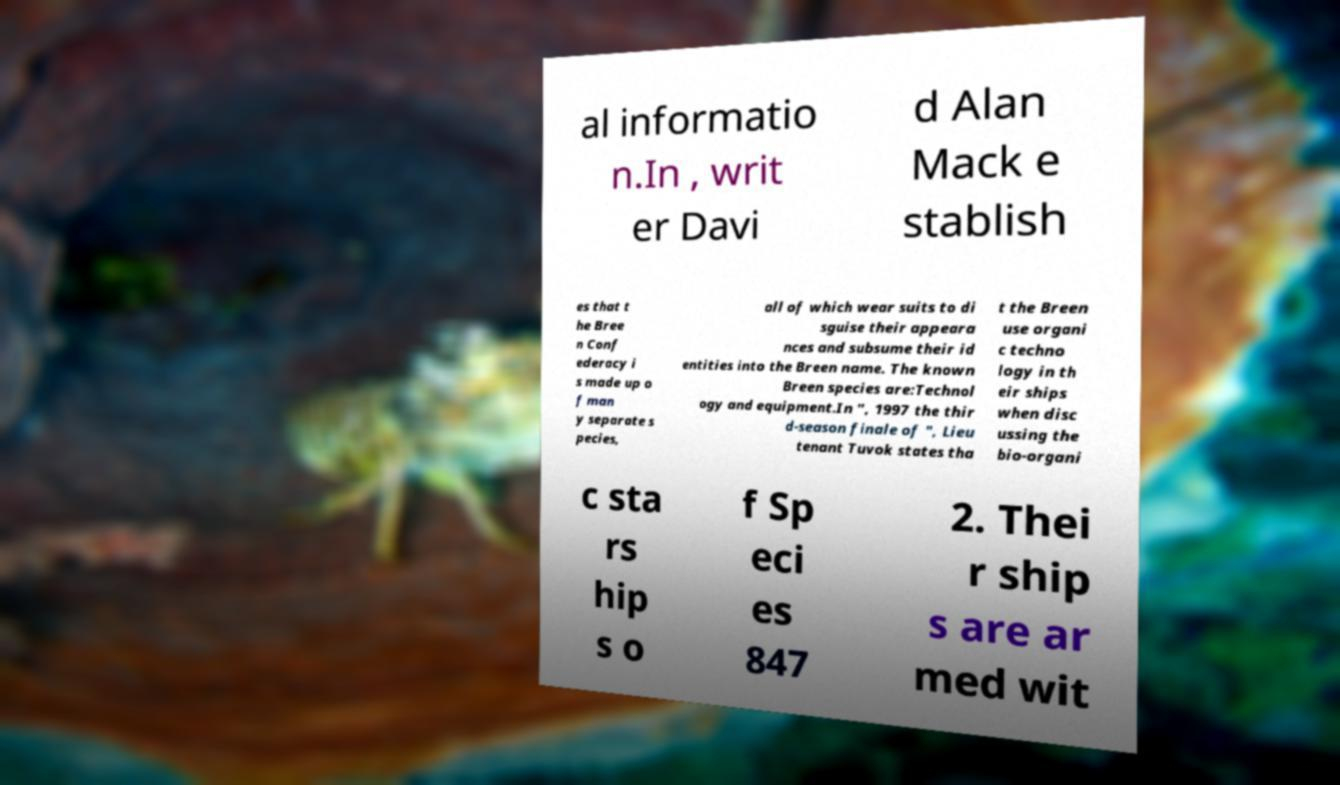Could you assist in decoding the text presented in this image and type it out clearly? al informatio n.In , writ er Davi d Alan Mack e stablish es that t he Bree n Conf ederacy i s made up o f man y separate s pecies, all of which wear suits to di sguise their appeara nces and subsume their id entities into the Breen name. The known Breen species are:Technol ogy and equipment.In ", 1997 the thir d-season finale of ", Lieu tenant Tuvok states tha t the Breen use organi c techno logy in th eir ships when disc ussing the bio-organi c sta rs hip s o f Sp eci es 847 2. Thei r ship s are ar med wit 